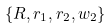Convert formula to latex. <formula><loc_0><loc_0><loc_500><loc_500>\{ R , r _ { 1 } , r _ { 2 } , w _ { 2 } \}</formula> 